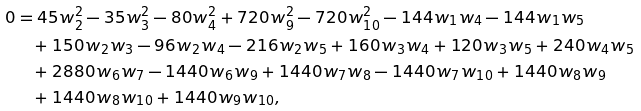Convert formula to latex. <formula><loc_0><loc_0><loc_500><loc_500>0 & = 4 5 w _ { 2 } ^ { 2 } - 3 5 w _ { 3 } ^ { 2 } - 8 0 w _ { 4 } ^ { 2 } + 7 2 0 w _ { 9 } ^ { 2 } - 7 2 0 w _ { 1 0 } ^ { 2 } - 1 4 4 w _ { 1 } w _ { 4 } - 1 4 4 w _ { 1 } w _ { 5 } \\ & \quad + 1 5 0 w _ { 2 } w _ { 3 } - 9 6 w _ { 2 } w _ { 4 } - 2 1 6 w _ { 2 } w _ { 5 } + 1 6 0 w _ { 3 } w _ { 4 } + 1 2 0 w _ { 3 } w _ { 5 } + 2 4 0 w _ { 4 } w _ { 5 } \\ & \quad + 2 8 8 0 w _ { 6 } w _ { 7 } - 1 4 4 0 w _ { 6 } w _ { 9 } + 1 4 4 0 w _ { 7 } w _ { 8 } - 1 4 4 0 w _ { 7 } w _ { 1 0 } + 1 4 4 0 w _ { 8 } w _ { 9 } \\ & \quad + 1 4 4 0 w _ { 8 } w _ { 1 0 } + 1 4 4 0 w _ { 9 } w _ { 1 0 } ,</formula> 